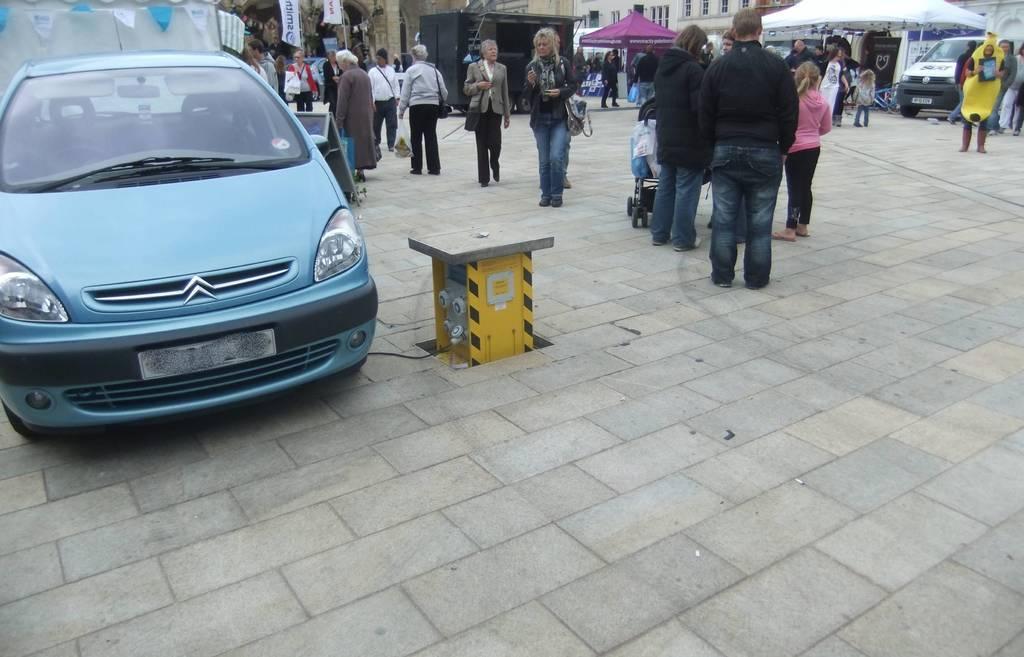Could you give a brief overview of what you see in this image? In the picture we can see the tiles. On the tiles, we can see a car which is in a blue color. Beside the car, we can see a few people are walking and few people are standing. In the background we can see some stalls and a part of the building with windows. 